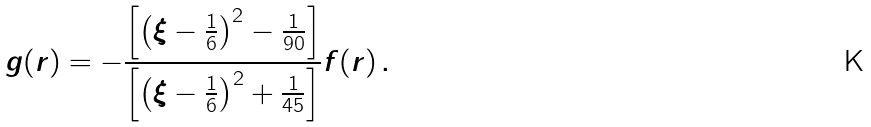<formula> <loc_0><loc_0><loc_500><loc_500>g ( r ) = - \frac { \left [ \left ( \xi - \frac { 1 } { 6 } \right ) ^ { 2 } - \frac { 1 } { 9 0 } \right ] } { \left [ \left ( \xi - \frac { 1 } { 6 } \right ) ^ { 2 } + \frac { 1 } { 4 5 } \right ] } f ( r ) \, .</formula> 